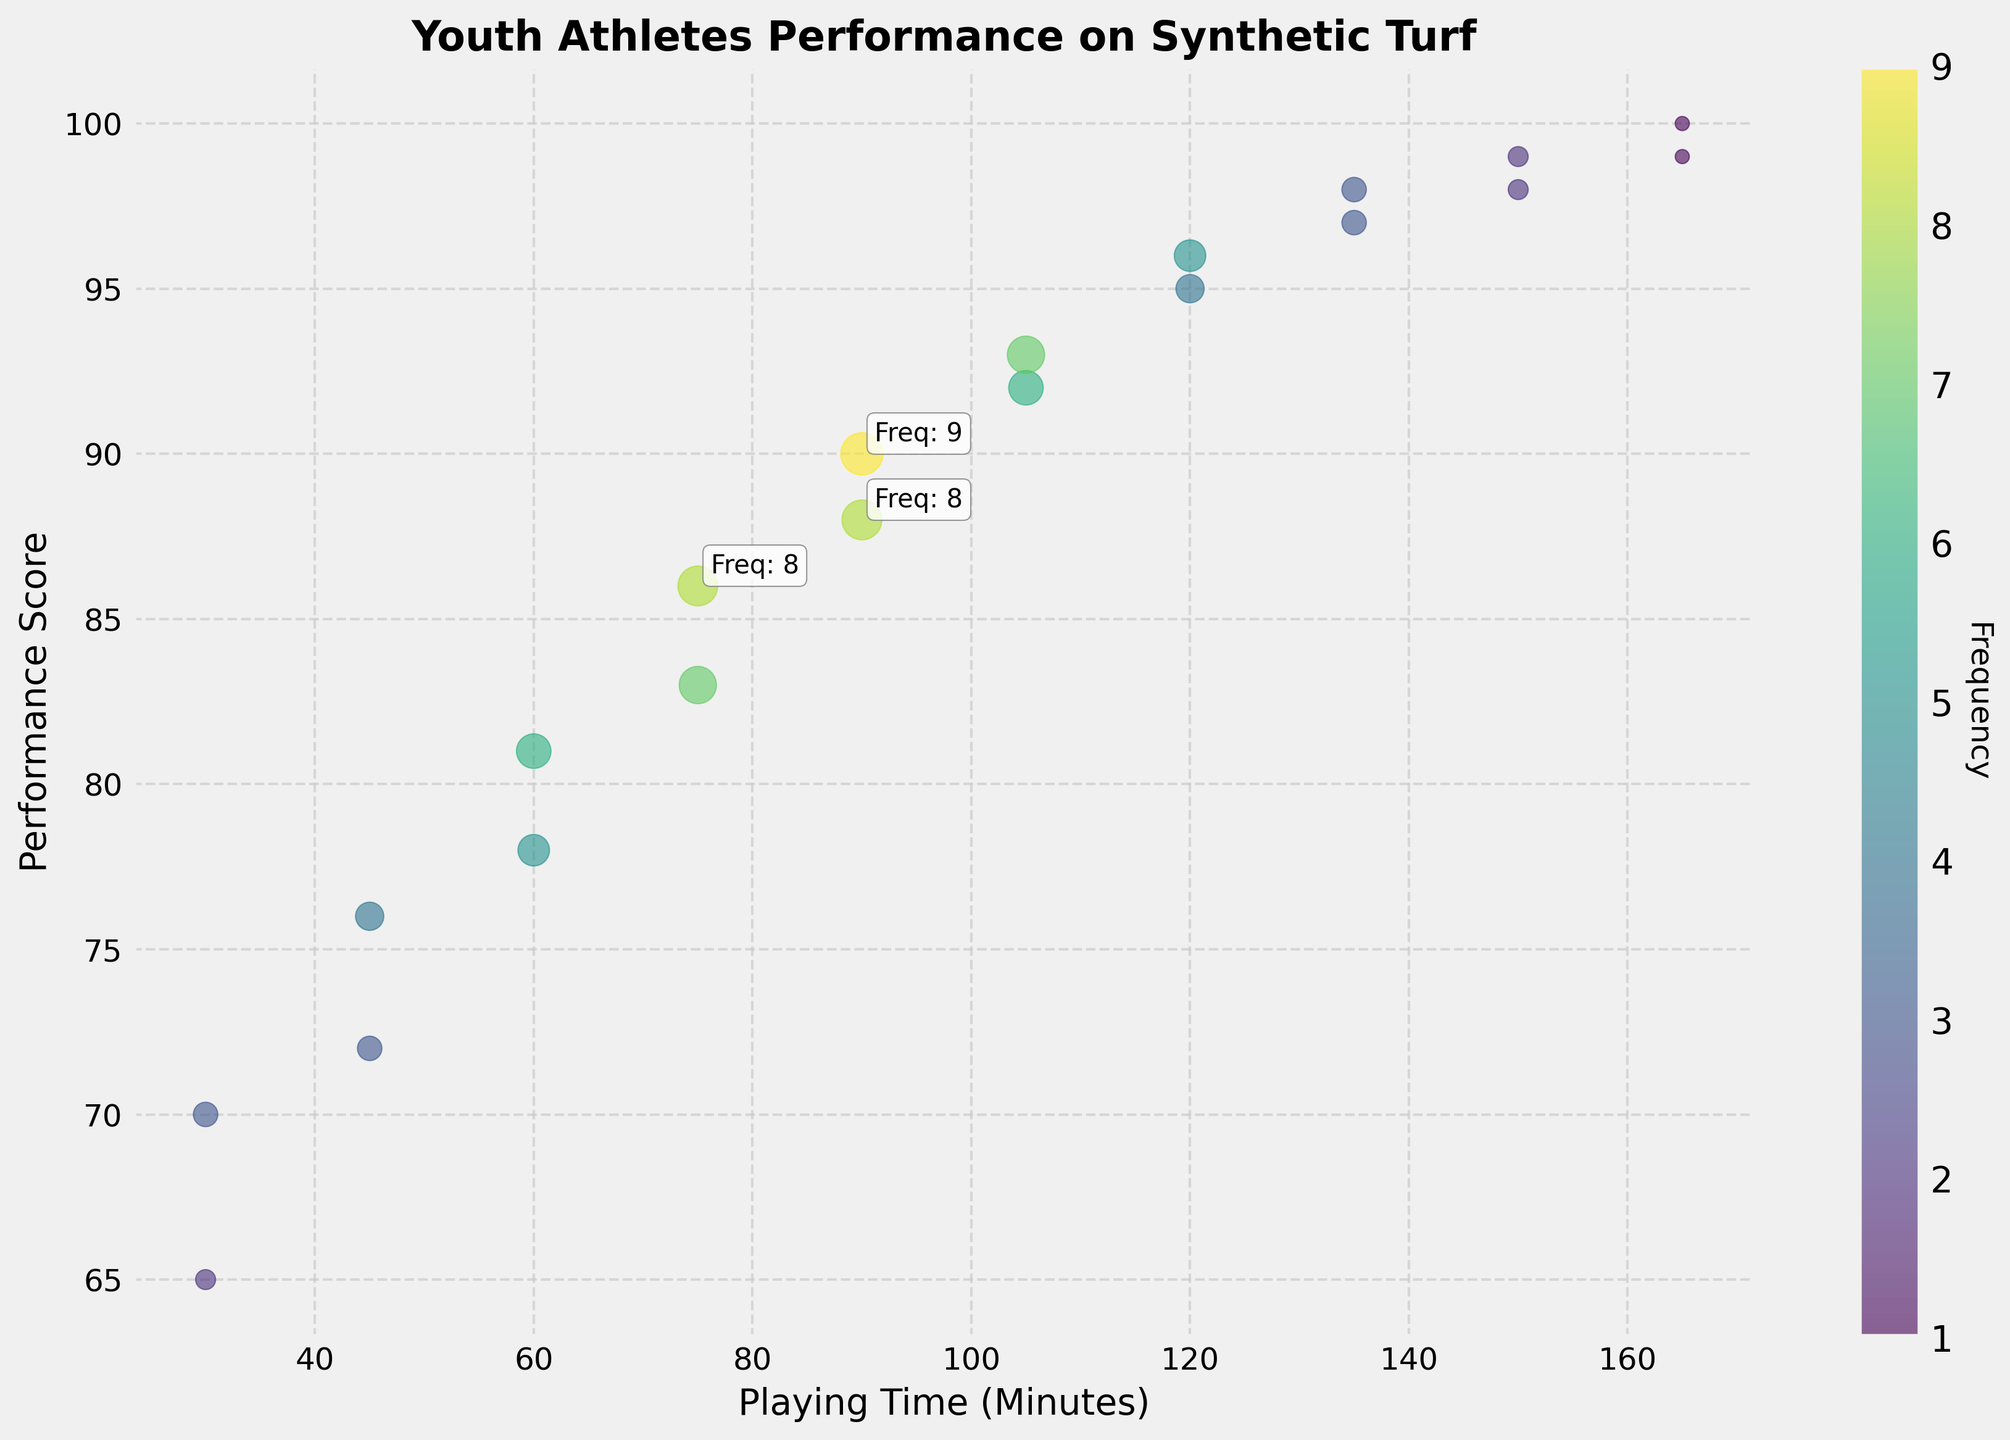What's the title of the plot? The title is usually displayed in a larger font at the top of the plot, and it describes the main subject of the plot. In this case, the title is "Youth Athletes Performance on Synthetic Turf".
Answer: Youth Athletes Performance on Synthetic Turf What is the label of the x-axis? The label of the x-axis is usually located along the bottom horizontal line of the plot, and it describes what the numbers on that axis represent. Here, it is "Playing Time (Minutes)".
Answer: Playing Time (Minutes) Which playing time interval has the highest performance score? By looking at the scatter points, the highest performance score is indicated on the vertical axis, which reaches 100 and corresponds to a playing time of 165 minutes.
Answer: 165 minutes How many data points have a frequency higher than 7? By checking the annotations and the sizes of the scatter points, we notice points with frequency mentions greater than 7. There are three data points that have a frequency higher than 7.
Answer: 3 data points What color is used to represent the highest frequency? The color representing the highest frequency can be deduced by observing the color bar. The highest frequency is represented by the darkest or most saturated color in the viridis colormap, which is a dark green.
Answer: Dark green What is the playing time and performance score for the point with the highest frequency? The largest bubble or the most prominent annotated point indicates the highest frequency. From the annotations, the highest frequency (9) corresponds to a playing time of 90 minutes and a performance score of 90.
Answer: 90 minutes, 90 performance score What is the average playing time for scores between 80 and 100? We need to identify the data points with scores between 80 and 100, sum their playing times, and divide by the number of those points. The relevant playing times are 60, 75, 90, 105, 120, 135, 150, 165. The sum is 60 + 75 + 90 + 105 + 120 + 135 + 150 + 165 = 900. There are 8 points, so the average is 900/8 = 112.5.
Answer: 112.5 minutes What is the difference in performance score between the points with playing times of 45 and 120 minutes? Find the performance scores for playing times of 45 and 120 minutes from the plot. For 45 minutes, scores are around 72 and 76. For 120 minutes, scores are around 95 and 96. Calculate the difference for each pair and take an average if necessary. For simplicity, a typical difference is 96 - 72 = 24 and 95 - 76 = 19. A rough mean difference could be 21.5.
Answer: Around 21.5 points Which playing time interval shows the widest range of performance scores? Identify the intervals on the x-axis and compare the range (difference between highest and lowest) of performance scores for each interval. The interval for 30 minutes shows a performance score ranging between 65 and 70, the widest visible range in this context.
Answer: 30 minutesinterval 